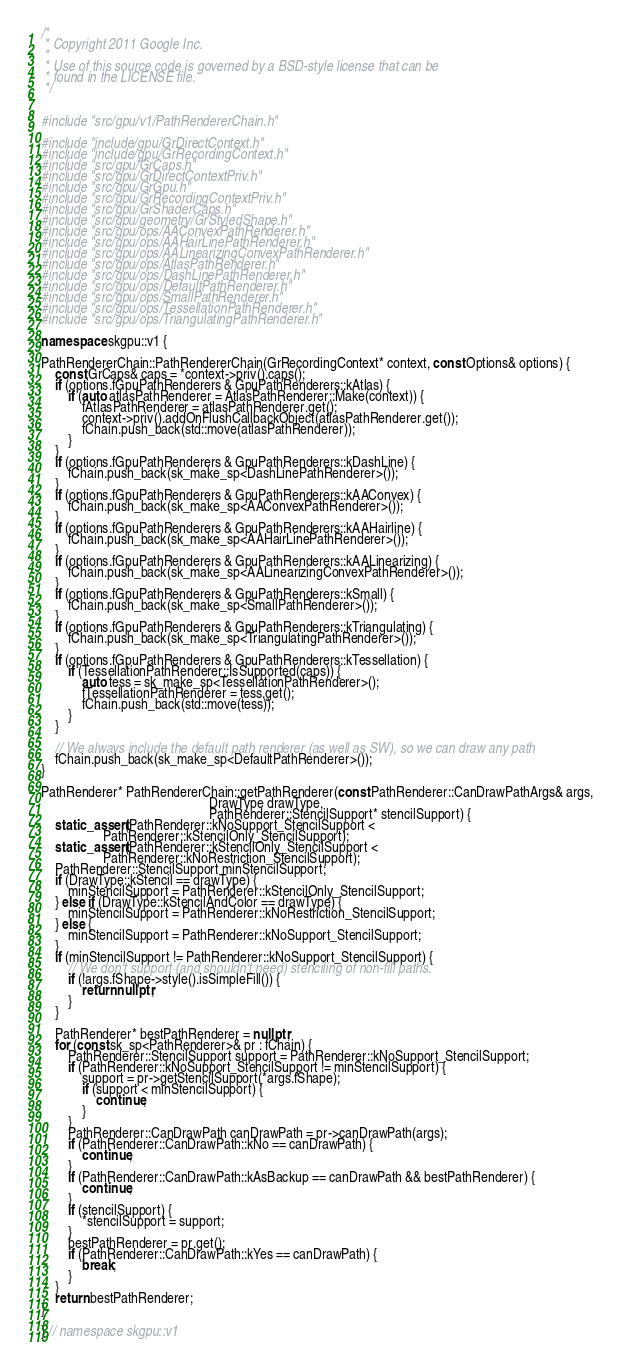Convert code to text. <code><loc_0><loc_0><loc_500><loc_500><_C++_>/*
 * Copyright 2011 Google Inc.
 *
 * Use of this source code is governed by a BSD-style license that can be
 * found in the LICENSE file.
 */


#include "src/gpu/v1/PathRendererChain.h"

#include "include/gpu/GrDirectContext.h"
#include "include/gpu/GrRecordingContext.h"
#include "src/gpu/GrCaps.h"
#include "src/gpu/GrDirectContextPriv.h"
#include "src/gpu/GrGpu.h"
#include "src/gpu/GrRecordingContextPriv.h"
#include "src/gpu/GrShaderCaps.h"
#include "src/gpu/geometry/GrStyledShape.h"
#include "src/gpu/ops/AAConvexPathRenderer.h"
#include "src/gpu/ops/AAHairLinePathRenderer.h"
#include "src/gpu/ops/AALinearizingConvexPathRenderer.h"
#include "src/gpu/ops/AtlasPathRenderer.h"
#include "src/gpu/ops/DashLinePathRenderer.h"
#include "src/gpu/ops/DefaultPathRenderer.h"
#include "src/gpu/ops/SmallPathRenderer.h"
#include "src/gpu/ops/TessellationPathRenderer.h"
#include "src/gpu/ops/TriangulatingPathRenderer.h"

namespace skgpu::v1 {

PathRendererChain::PathRendererChain(GrRecordingContext* context, const Options& options) {
    const GrCaps& caps = *context->priv().caps();
    if (options.fGpuPathRenderers & GpuPathRenderers::kAtlas) {
        if (auto atlasPathRenderer = AtlasPathRenderer::Make(context)) {
            fAtlasPathRenderer = atlasPathRenderer.get();
            context->priv().addOnFlushCallbackObject(atlasPathRenderer.get());
            fChain.push_back(std::move(atlasPathRenderer));
        }
    }
    if (options.fGpuPathRenderers & GpuPathRenderers::kDashLine) {
        fChain.push_back(sk_make_sp<DashLinePathRenderer>());
    }
    if (options.fGpuPathRenderers & GpuPathRenderers::kAAConvex) {
        fChain.push_back(sk_make_sp<AAConvexPathRenderer>());
    }
    if (options.fGpuPathRenderers & GpuPathRenderers::kAAHairline) {
        fChain.push_back(sk_make_sp<AAHairLinePathRenderer>());
    }
    if (options.fGpuPathRenderers & GpuPathRenderers::kAALinearizing) {
        fChain.push_back(sk_make_sp<AALinearizingConvexPathRenderer>());
    }
    if (options.fGpuPathRenderers & GpuPathRenderers::kSmall) {
        fChain.push_back(sk_make_sp<SmallPathRenderer>());
    }
    if (options.fGpuPathRenderers & GpuPathRenderers::kTriangulating) {
        fChain.push_back(sk_make_sp<TriangulatingPathRenderer>());
    }
    if (options.fGpuPathRenderers & GpuPathRenderers::kTessellation) {
        if (TessellationPathRenderer::IsSupported(caps)) {
            auto tess = sk_make_sp<TessellationPathRenderer>();
            fTessellationPathRenderer = tess.get();
            fChain.push_back(std::move(tess));
        }
    }

    // We always include the default path renderer (as well as SW), so we can draw any path
    fChain.push_back(sk_make_sp<DefaultPathRenderer>());
}

PathRenderer* PathRendererChain::getPathRenderer(const PathRenderer::CanDrawPathArgs& args,
                                                 DrawType drawType,
                                                 PathRenderer::StencilSupport* stencilSupport) {
    static_assert(PathRenderer::kNoSupport_StencilSupport <
                  PathRenderer::kStencilOnly_StencilSupport);
    static_assert(PathRenderer::kStencilOnly_StencilSupport <
                  PathRenderer::kNoRestriction_StencilSupport);
    PathRenderer::StencilSupport minStencilSupport;
    if (DrawType::kStencil == drawType) {
        minStencilSupport = PathRenderer::kStencilOnly_StencilSupport;
    } else if (DrawType::kStencilAndColor == drawType) {
        minStencilSupport = PathRenderer::kNoRestriction_StencilSupport;
    } else {
        minStencilSupport = PathRenderer::kNoSupport_StencilSupport;
    }
    if (minStencilSupport != PathRenderer::kNoSupport_StencilSupport) {
        // We don't support (and shouldn't need) stenciling of non-fill paths.
        if (!args.fShape->style().isSimpleFill()) {
            return nullptr;
        }
    }

    PathRenderer* bestPathRenderer = nullptr;
    for (const sk_sp<PathRenderer>& pr : fChain) {
        PathRenderer::StencilSupport support = PathRenderer::kNoSupport_StencilSupport;
        if (PathRenderer::kNoSupport_StencilSupport != minStencilSupport) {
            support = pr->getStencilSupport(*args.fShape);
            if (support < minStencilSupport) {
                continue;
            }
        }
        PathRenderer::CanDrawPath canDrawPath = pr->canDrawPath(args);
        if (PathRenderer::CanDrawPath::kNo == canDrawPath) {
            continue;
        }
        if (PathRenderer::CanDrawPath::kAsBackup == canDrawPath && bestPathRenderer) {
            continue;
        }
        if (stencilSupport) {
            *stencilSupport = support;
        }
        bestPathRenderer = pr.get();
        if (PathRenderer::CanDrawPath::kYes == canDrawPath) {
            break;
        }
    }
    return bestPathRenderer;
}

} // namespace skgpu::v1
</code> 